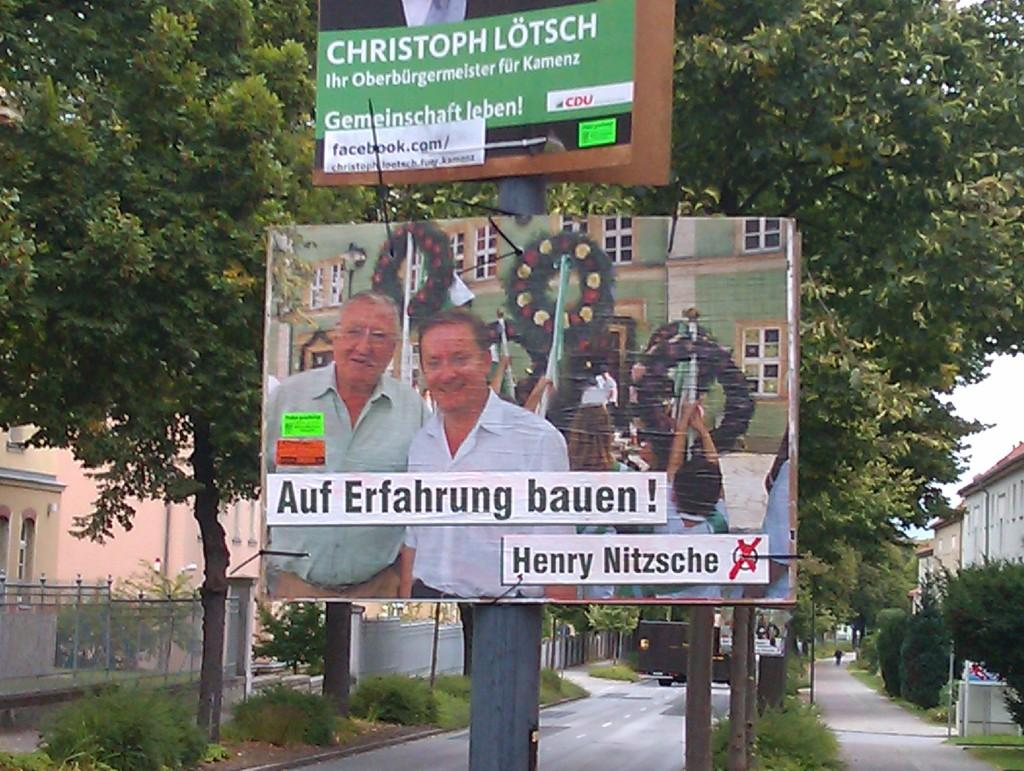<image>
Describe the image concisely. A sign on a street pole that says "Auf Erfahrung bauen! Henry Nitzsche 